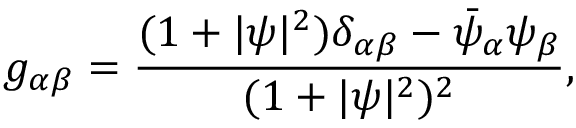Convert formula to latex. <formula><loc_0><loc_0><loc_500><loc_500>g _ { \alpha \beta } = \frac { ( 1 + | \psi | ^ { 2 } ) \delta _ { \alpha \beta } - \bar { \psi } _ { \alpha } \psi _ { \beta } } { ( 1 + | \psi | ^ { 2 } ) ^ { 2 } } ,</formula> 